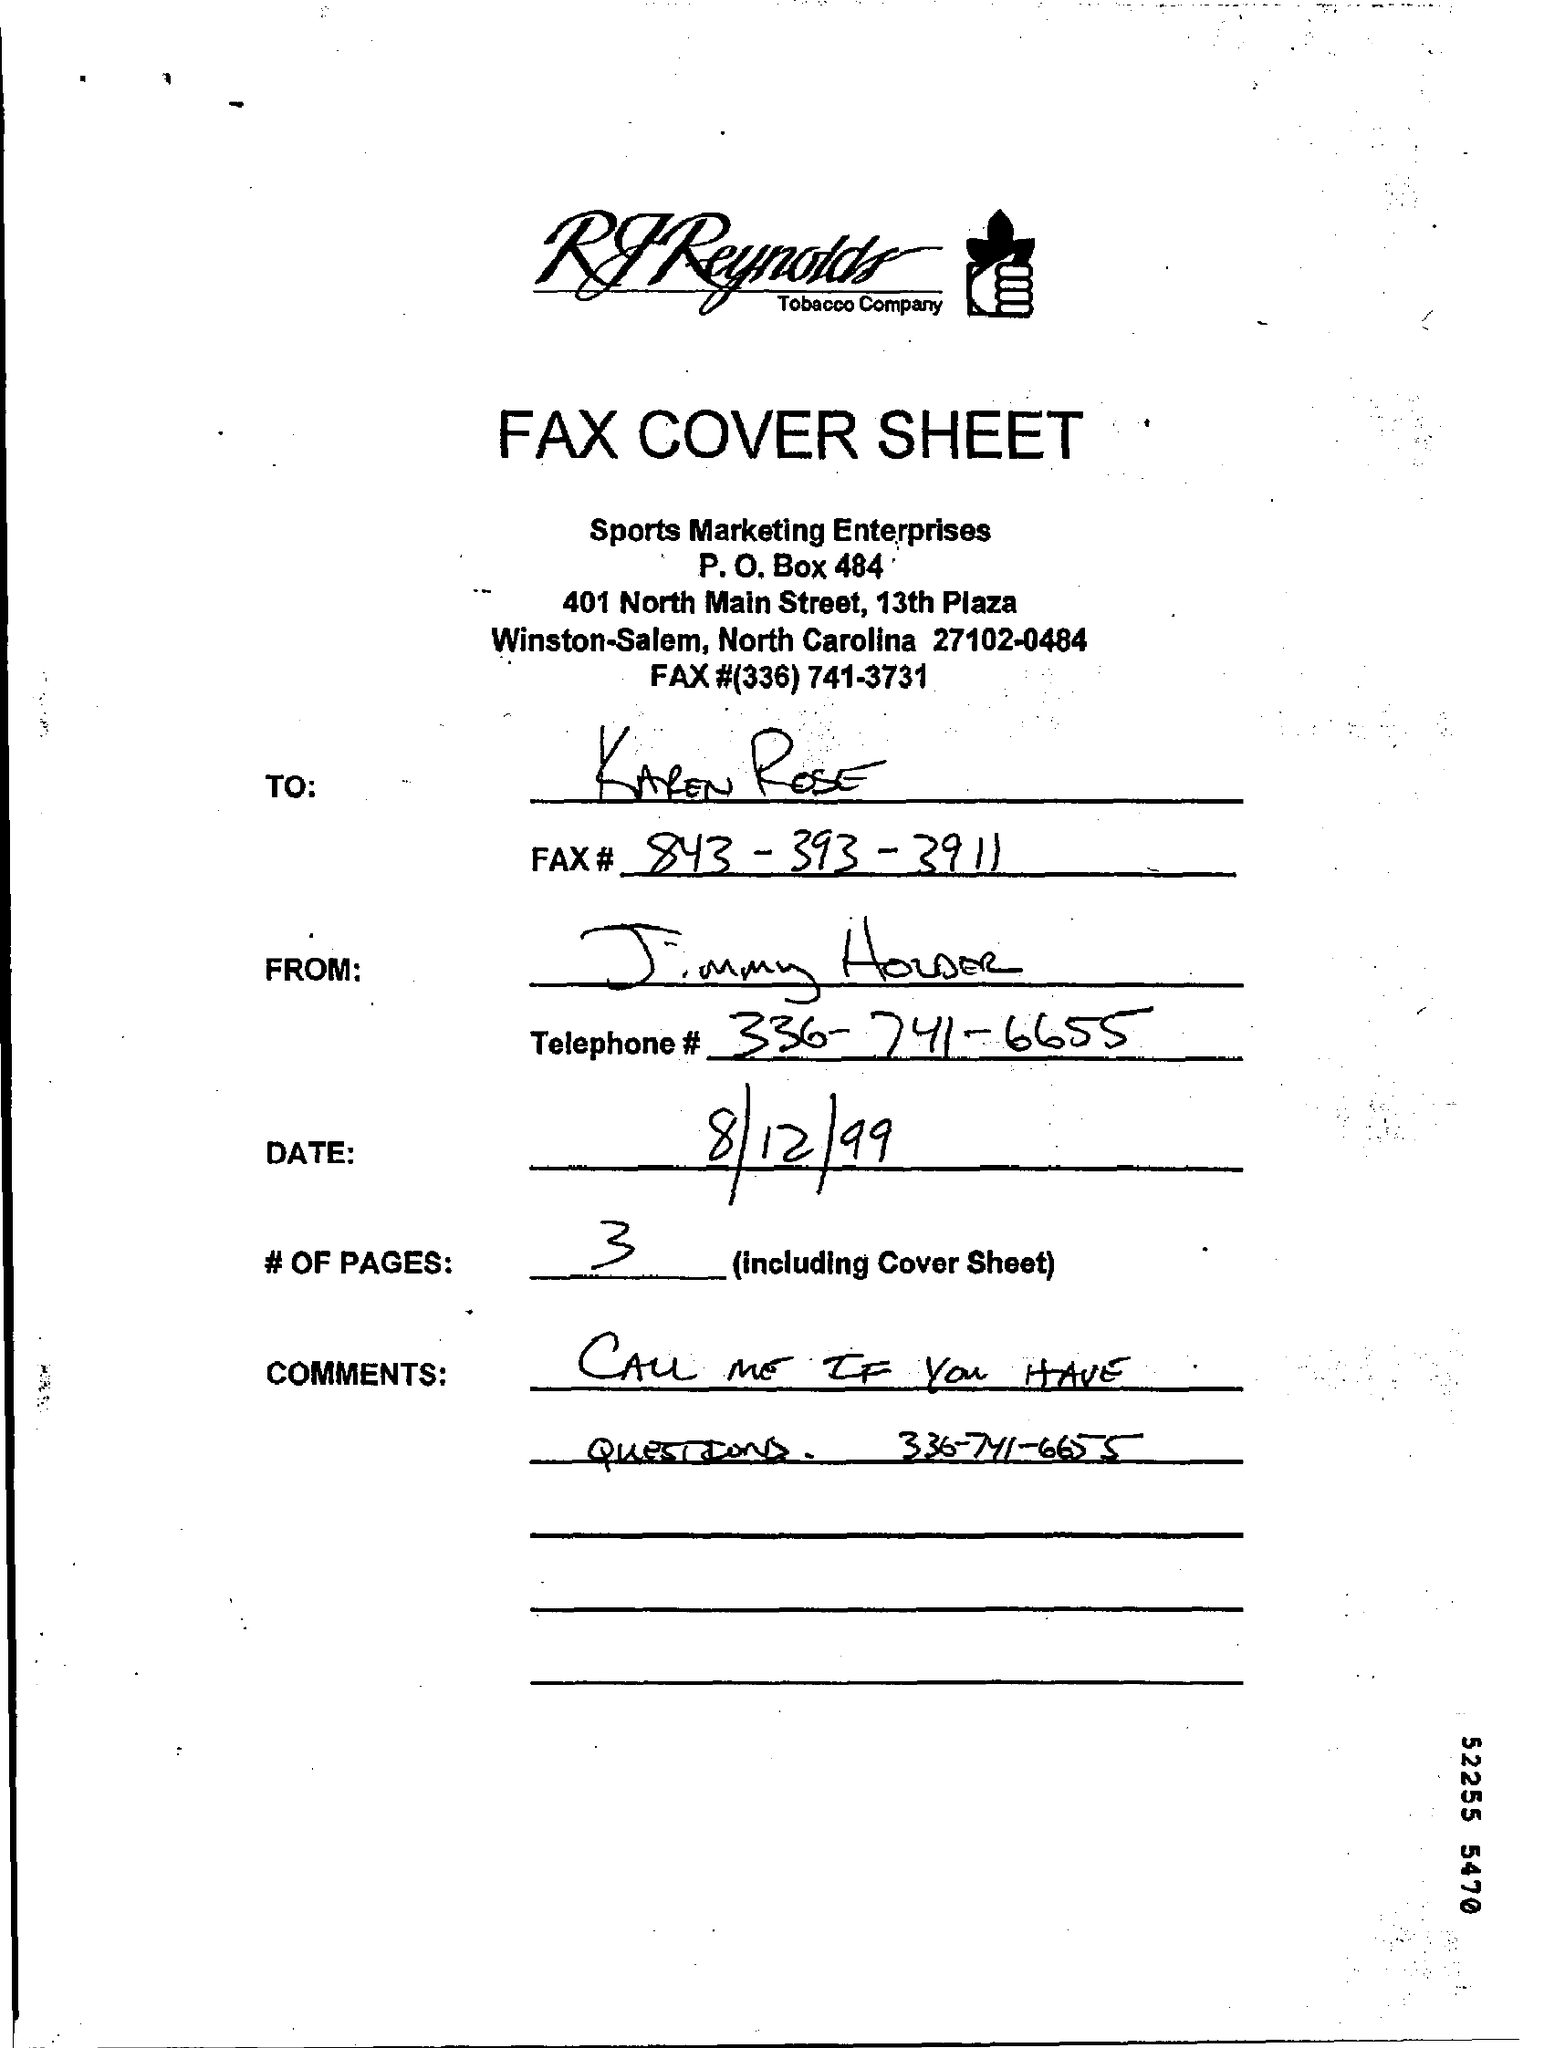What is the p.o. box no ?
Offer a terse response. 484. What is the name of the street ?
Keep it short and to the point. North Main Street. What is the date mentioned ?
Provide a short and direct response. 8/12/99. How many #of pages (including cover sheet )
Give a very brief answer. 3. What is the fax# number of karen rose ?
Your answer should be very brief. 843-393-3911. What is the telephone# number of jimmy houser ?
Keep it short and to the point. 336-741-6655. What is the name of the enterprises ?
Your answer should be very brief. Sports Marketing Enterprises. 